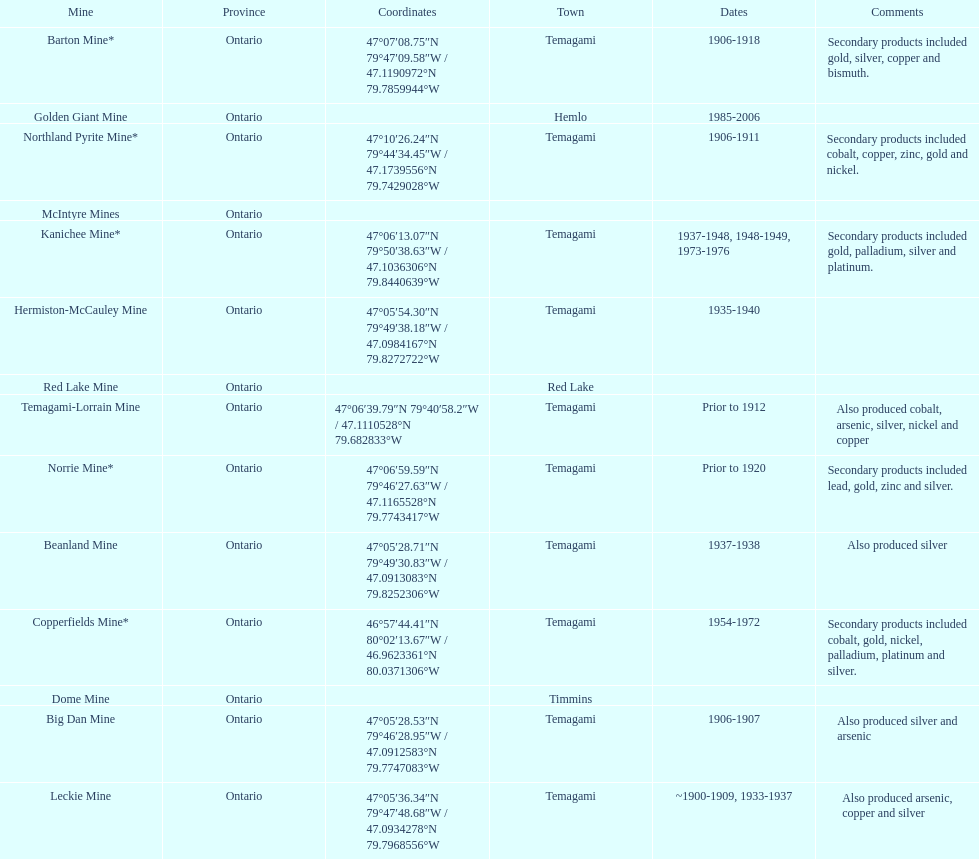Tell me the number of mines that also produced arsenic. 3. 